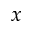<formula> <loc_0><loc_0><loc_500><loc_500>x</formula> 